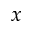<formula> <loc_0><loc_0><loc_500><loc_500>x</formula> 